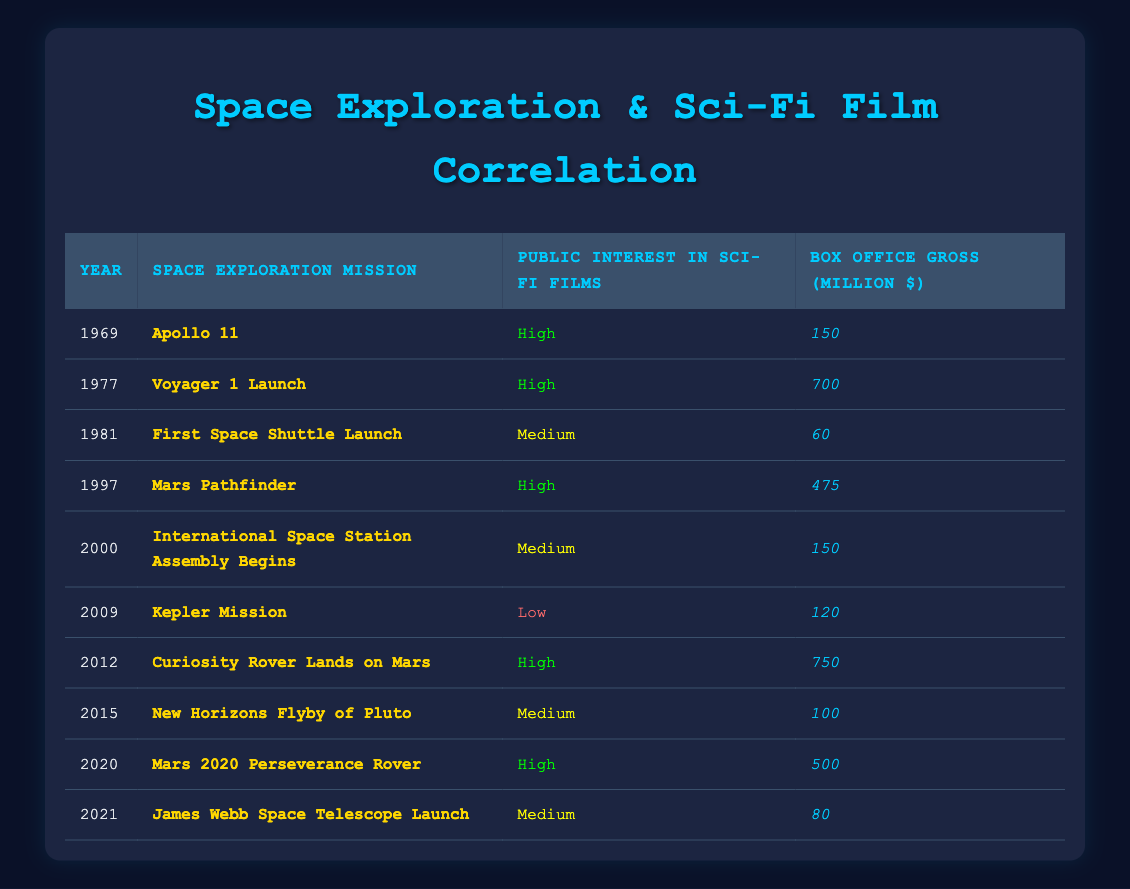What was the box office gross for the Apollo 11 mission year? The Apollo 11 mission occurred in 1969, and the corresponding box office gross listed in the table is 150 million dollars.
Answer: 150 million Which year had the highest box office gross related to a space exploration mission? In the table, the highest box office gross is 750 million dollars, which corresponds to the Curiosity Rover landing on Mars in 2012.
Answer: 2012 How many missions show "Medium" public interest in sci-fi films? By reviewing the table, I find three missions labeled with "Medium" public interest: First Space Shuttle Launch (1981), International Space Station Assembly Begins (2000), and New Horizons Flyby of Pluto (2015).
Answer: 3 What was the average box office gross for missions with "High" public interest? The box office grosses for "High" public interest missions are: 150 (Apollo 11) + 700 (Voyager 1 Launch) + 475 (Mars Pathfinder) + 750 (Curiosity Rover) + 500 (Mars 2020) = 2575 million dollars. There are 5 such missions, so the average is 2575 / 5 = 515 million dollars.
Answer: 515 million Was the public interest in sci-fi films low during the year of the Kepler Mission? Looking at the rows in the table, the Kepler Mission occurred in 2009, and it is marked as "Low" for public interest in sci-fi films.
Answer: Yes Which year(s) correspond to both "High" public interest and the lowest box office gross? The years with "High" public interest are 1969 (150 million), 1977 (700 million), 1997 (475 million), 2012 (750 million), and 2020 (500 million). Among these, 1969 has the lowest box office gross at 150 million dollars.
Answer: 1969 What is the difference in box office gross between the years 2012 and 2021? The box office gross for 2012 (Curiosity Rover) is 750 million, while for 2021 (James Webb Space Telescope) it is 80 million. The difference is calculated as 750 - 80 = 670 million dollars.
Answer: 670 million Which space exploration mission had "Medium" public interest and the highest box office gross? By examining the table, the mission with "Medium" public interest that also has the highest gross is the First Space Shuttle Launch from 1981, which grossed 60 million.
Answer: 60 million 